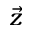Convert formula to latex. <formula><loc_0><loc_0><loc_500><loc_500>\vec { z }</formula> 